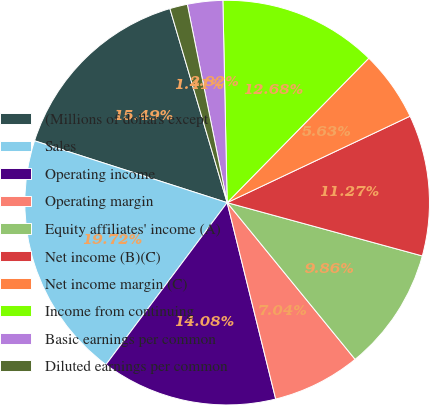<chart> <loc_0><loc_0><loc_500><loc_500><pie_chart><fcel>(Millions of dollars except<fcel>Sales<fcel>Operating income<fcel>Operating margin<fcel>Equity affiliates' income (A)<fcel>Net income (B)(C)<fcel>Net income margin (C)<fcel>Income from continuing<fcel>Basic earnings per common<fcel>Diluted earnings per common<nl><fcel>15.49%<fcel>19.72%<fcel>14.08%<fcel>7.04%<fcel>9.86%<fcel>11.27%<fcel>5.63%<fcel>12.68%<fcel>2.82%<fcel>1.41%<nl></chart> 